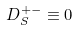<formula> <loc_0><loc_0><loc_500><loc_500>D _ { S } ^ { + - } \equiv 0</formula> 